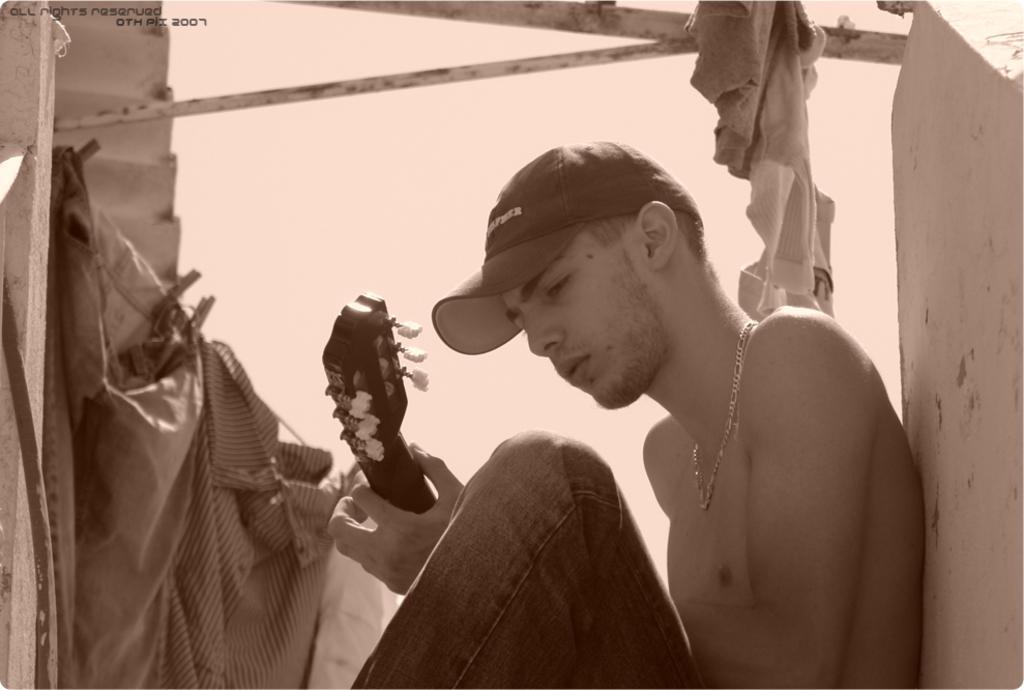In one or two sentences, can you explain what this image depicts? This is a black and white picture. Here we can see a man holding a musical instrument with his hand. This is rod and there are clothes. And there is a wall. 